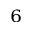<formula> <loc_0><loc_0><loc_500><loc_500>^ { 6 }</formula> 